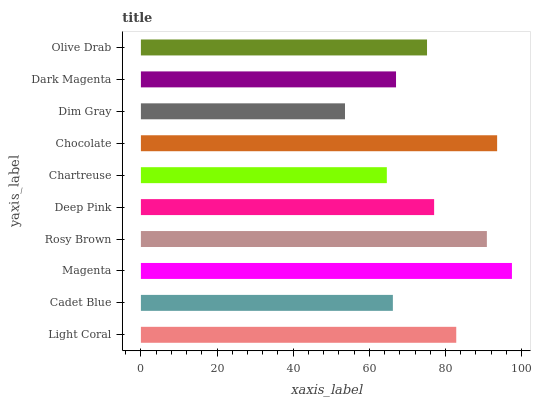Is Dim Gray the minimum?
Answer yes or no. Yes. Is Magenta the maximum?
Answer yes or no. Yes. Is Cadet Blue the minimum?
Answer yes or no. No. Is Cadet Blue the maximum?
Answer yes or no. No. Is Light Coral greater than Cadet Blue?
Answer yes or no. Yes. Is Cadet Blue less than Light Coral?
Answer yes or no. Yes. Is Cadet Blue greater than Light Coral?
Answer yes or no. No. Is Light Coral less than Cadet Blue?
Answer yes or no. No. Is Deep Pink the high median?
Answer yes or no. Yes. Is Olive Drab the low median?
Answer yes or no. Yes. Is Chartreuse the high median?
Answer yes or no. No. Is Cadet Blue the low median?
Answer yes or no. No. 